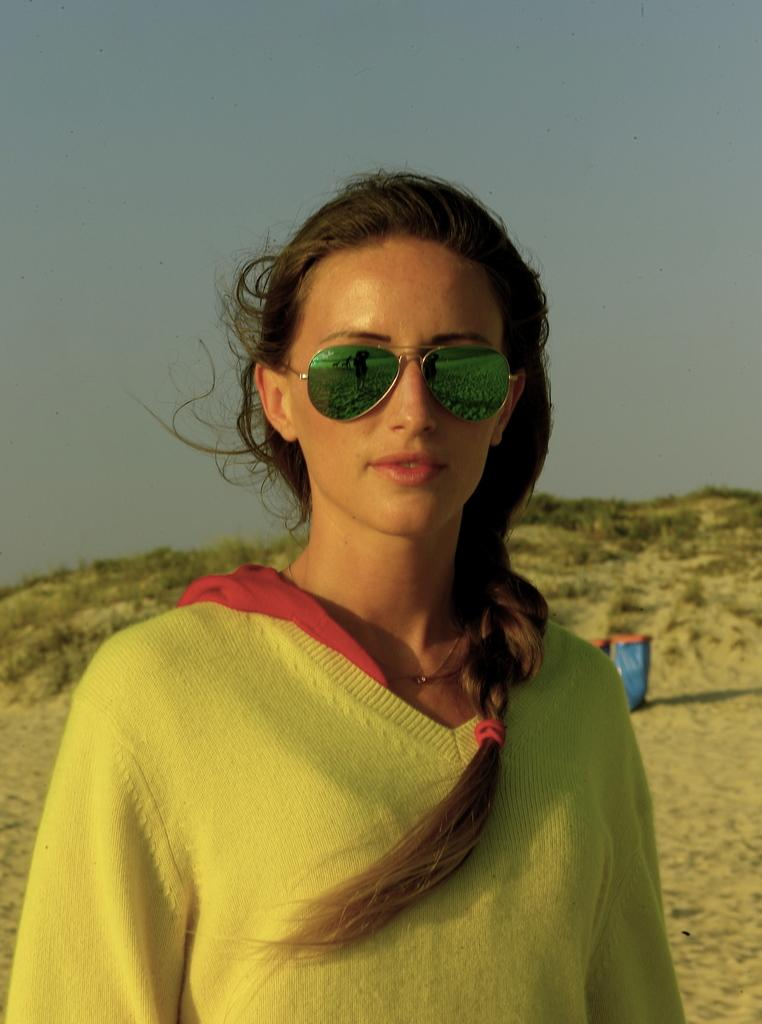What is the person in the image wearing? The person is wearing goggles. What can be seen in the background of the image? There is sand, a blue color object, grass, and the sky visible in the background of the image. What time of day is it in the image, and how does the person blow bubbles? The time of day is not mentioned in the image, and there is no indication of the person blowing bubbles. 